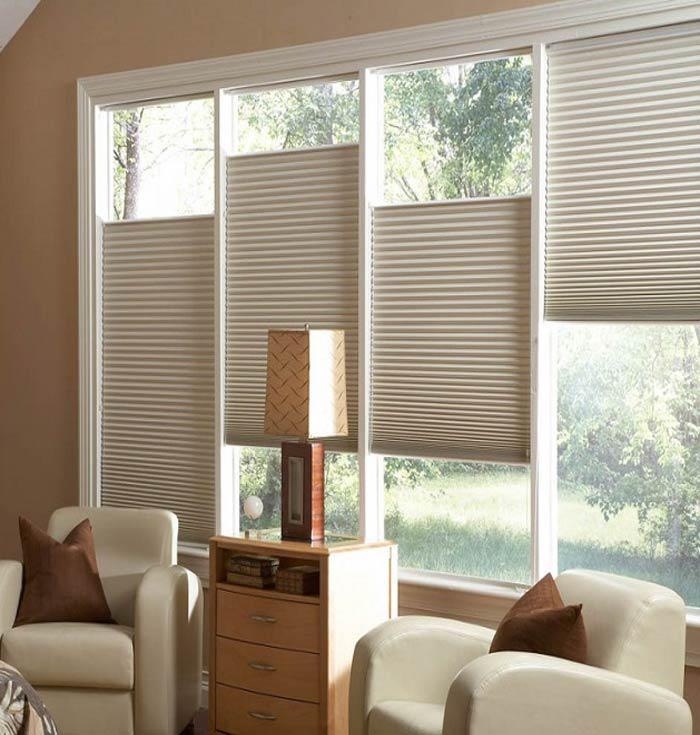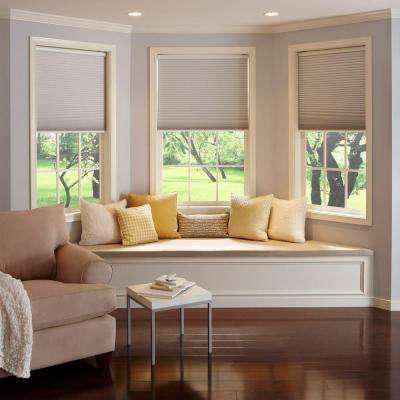The first image is the image on the left, the second image is the image on the right. Evaluate the accuracy of this statement regarding the images: "The left and right image contains a total of seven blinds.". Is it true? Answer yes or no. Yes. The first image is the image on the left, the second image is the image on the right. Assess this claim about the two images: "The left image shows three window screens on windows.". Correct or not? Answer yes or no. No. 